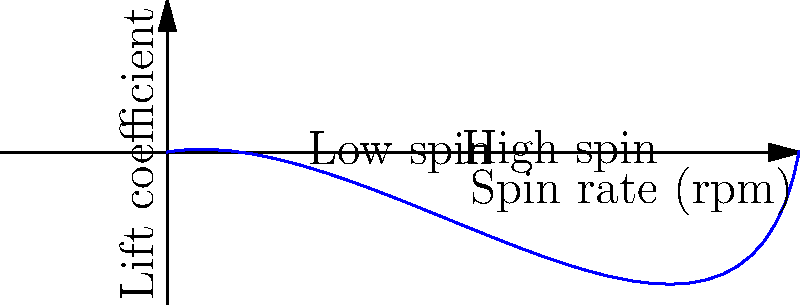As a rugby player, you're keen on understanding the physics behind your kicks. The graph shows the relationship between the spin rate of a rugby ball and its lift coefficient. Based on this, what effect would increasing the spin rate have on the ball's trajectory, and how might this impact your kicking strategy in windy conditions? Let's break this down step-by-step:

1. The graph shows a positive correlation between spin rate and lift coefficient. As the spin rate increases, the lift coefficient also increases.

2. In fluid dynamics, the lift coefficient is directly related to the amount of lift force generated. The lift force is given by the equation:

   $$F_L = \frac{1}{2} \rho v^2 S C_L$$

   where $F_L$ is the lift force, $\rho$ is air density, $v$ is velocity, $S$ is the reference area, and $C_L$ is the lift coefficient.

3. A higher lift coefficient means more lift force is generated for the same velocity and air density.

4. In the context of a spinning rugby ball, this lift force is what causes the ball to deviate from a straight path, creating the familiar curved trajectory.

5. Increasing the spin rate would result in a higher lift coefficient, which in turn would lead to a greater lift force and a more pronounced curve in the ball's trajectory.

6. In windy conditions, this effect becomes even more significant. The wind can either enhance or counteract the lift force, depending on its direction relative to the ball's spin.

7. For a kicking strategy:
   - In a crosswind, you could use a higher spin rate to create a more pronounced curve, potentially "bending" the ball around the wind.
   - In a headwind, a higher spin rate could help the ball maintain lift and travel further.
   - In a tailwind, you might reduce the spin rate to prevent the ball from rising too much and overshooting the target.
Answer: Increasing spin rate enhances lift and curve, allowing for greater control in windy conditions. 